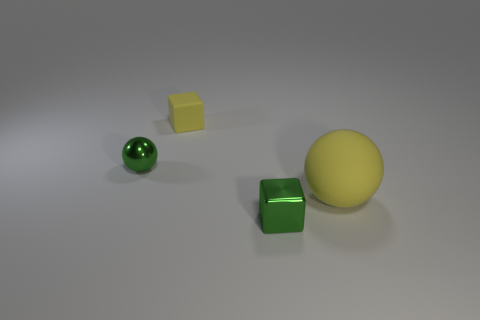Are there any things?
Provide a short and direct response. Yes. Is the shape of the small thing that is behind the tiny metallic ball the same as the small object that is in front of the rubber sphere?
Keep it short and to the point. Yes. How many big things are matte blocks or brown metallic things?
Provide a short and direct response. 0. There is a tiny object that is the same material as the big ball; what is its shape?
Your answer should be compact. Cube. Is the big yellow thing the same shape as the small yellow matte thing?
Offer a terse response. No. The big matte ball has what color?
Provide a succinct answer. Yellow. What number of objects are either tiny matte spheres or tiny blocks?
Provide a succinct answer. 2. Are there fewer tiny green metallic balls left of the yellow matte block than tiny objects?
Keep it short and to the point. Yes. Are there more green objects that are in front of the large rubber thing than metal cubes to the left of the small metal block?
Provide a succinct answer. Yes. Is there any other thing that is the same color as the tiny matte thing?
Your answer should be compact. Yes. 